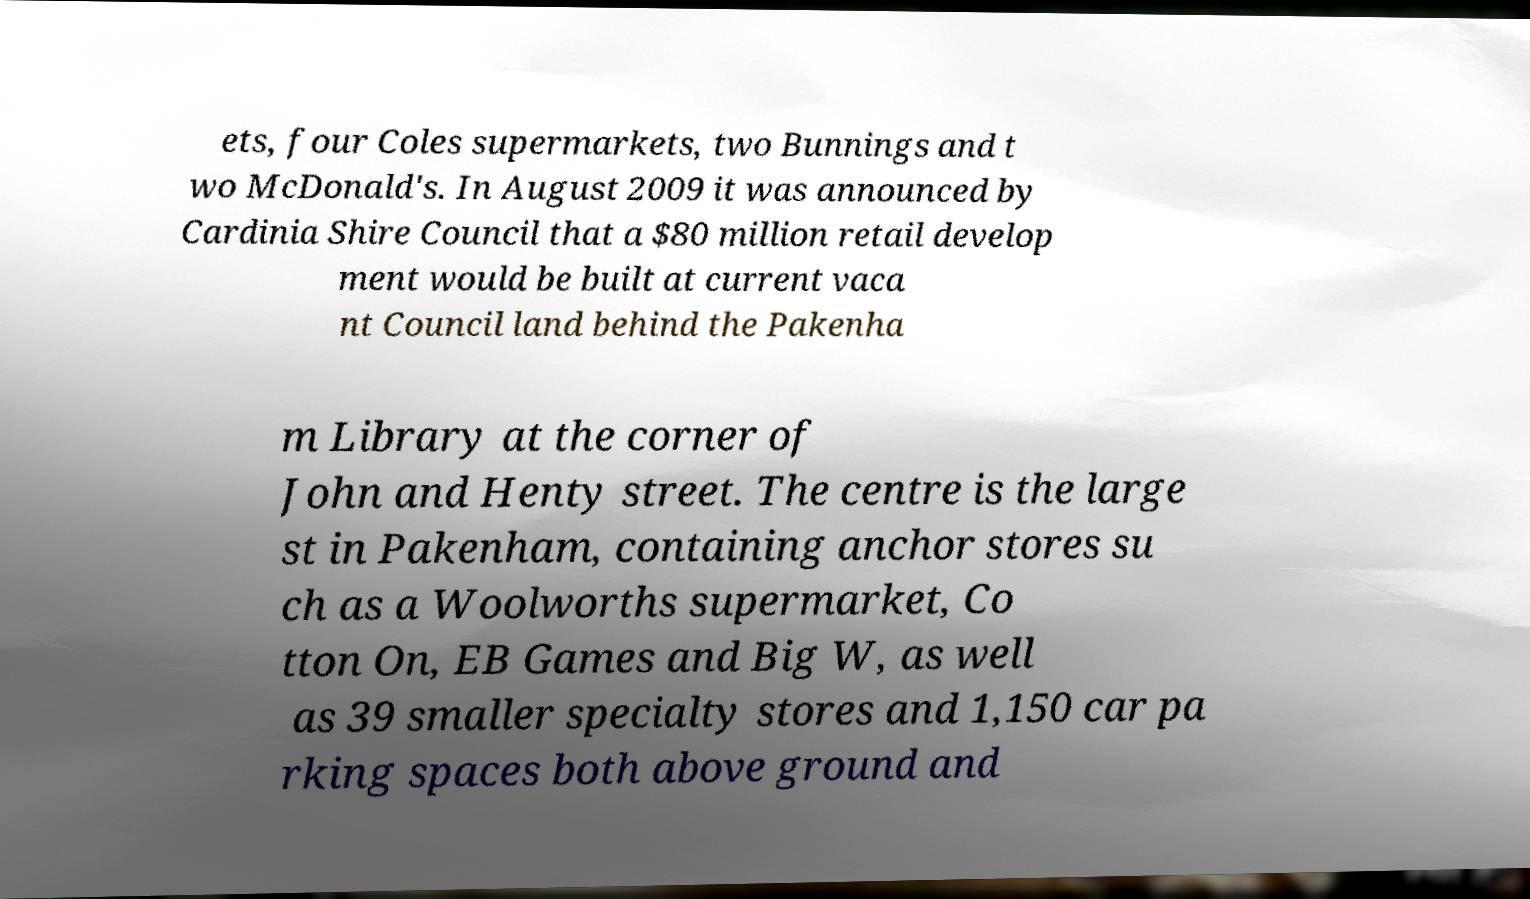I need the written content from this picture converted into text. Can you do that? ets, four Coles supermarkets, two Bunnings and t wo McDonald's. In August 2009 it was announced by Cardinia Shire Council that a $80 million retail develop ment would be built at current vaca nt Council land behind the Pakenha m Library at the corner of John and Henty street. The centre is the large st in Pakenham, containing anchor stores su ch as a Woolworths supermarket, Co tton On, EB Games and Big W, as well as 39 smaller specialty stores and 1,150 car pa rking spaces both above ground and 